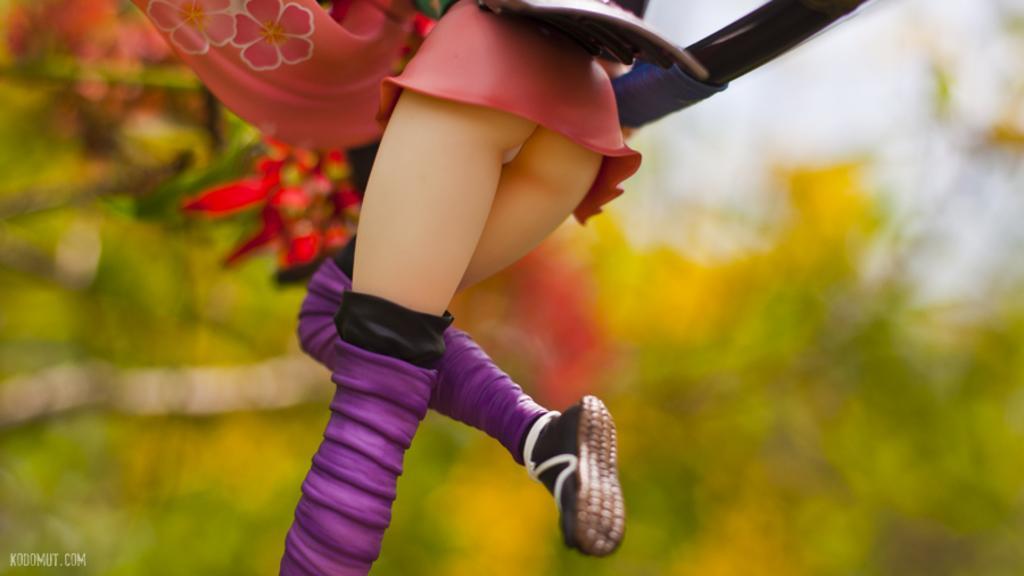Describe this image in one or two sentences. In this image there is a person wearing pink dress and purple boots. In the background there are trees. The background is blurry. 